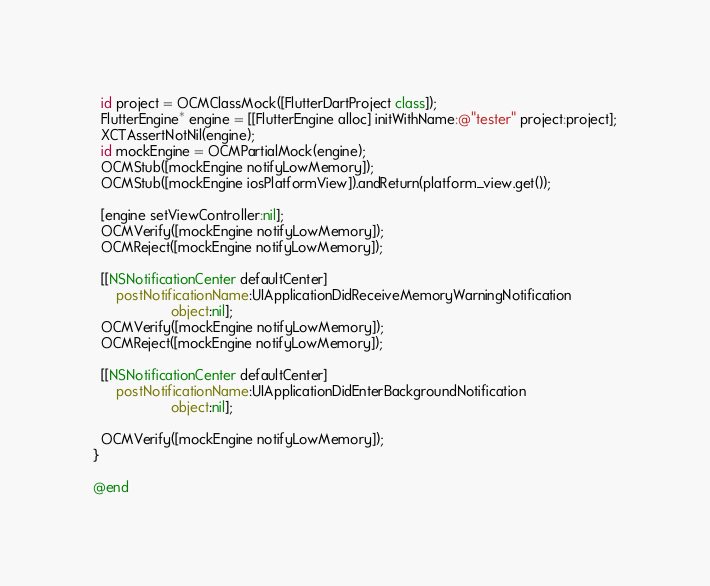Convert code to text. <code><loc_0><loc_0><loc_500><loc_500><_ObjectiveC_>
  id project = OCMClassMock([FlutterDartProject class]);
  FlutterEngine* engine = [[FlutterEngine alloc] initWithName:@"tester" project:project];
  XCTAssertNotNil(engine);
  id mockEngine = OCMPartialMock(engine);
  OCMStub([mockEngine notifyLowMemory]);
  OCMStub([mockEngine iosPlatformView]).andReturn(platform_view.get());

  [engine setViewController:nil];
  OCMVerify([mockEngine notifyLowMemory]);
  OCMReject([mockEngine notifyLowMemory]);

  [[NSNotificationCenter defaultCenter]
      postNotificationName:UIApplicationDidReceiveMemoryWarningNotification
                    object:nil];
  OCMVerify([mockEngine notifyLowMemory]);
  OCMReject([mockEngine notifyLowMemory]);

  [[NSNotificationCenter defaultCenter]
      postNotificationName:UIApplicationDidEnterBackgroundNotification
                    object:nil];

  OCMVerify([mockEngine notifyLowMemory]);
}

@end
</code> 